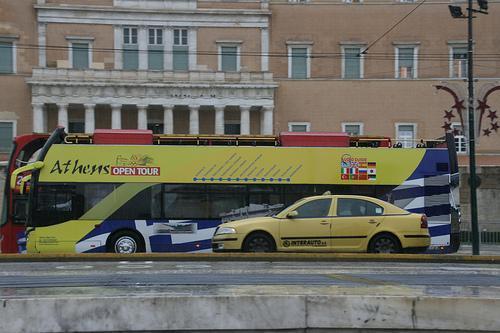How many cars are in the photograph?
Give a very brief answer. 1. 